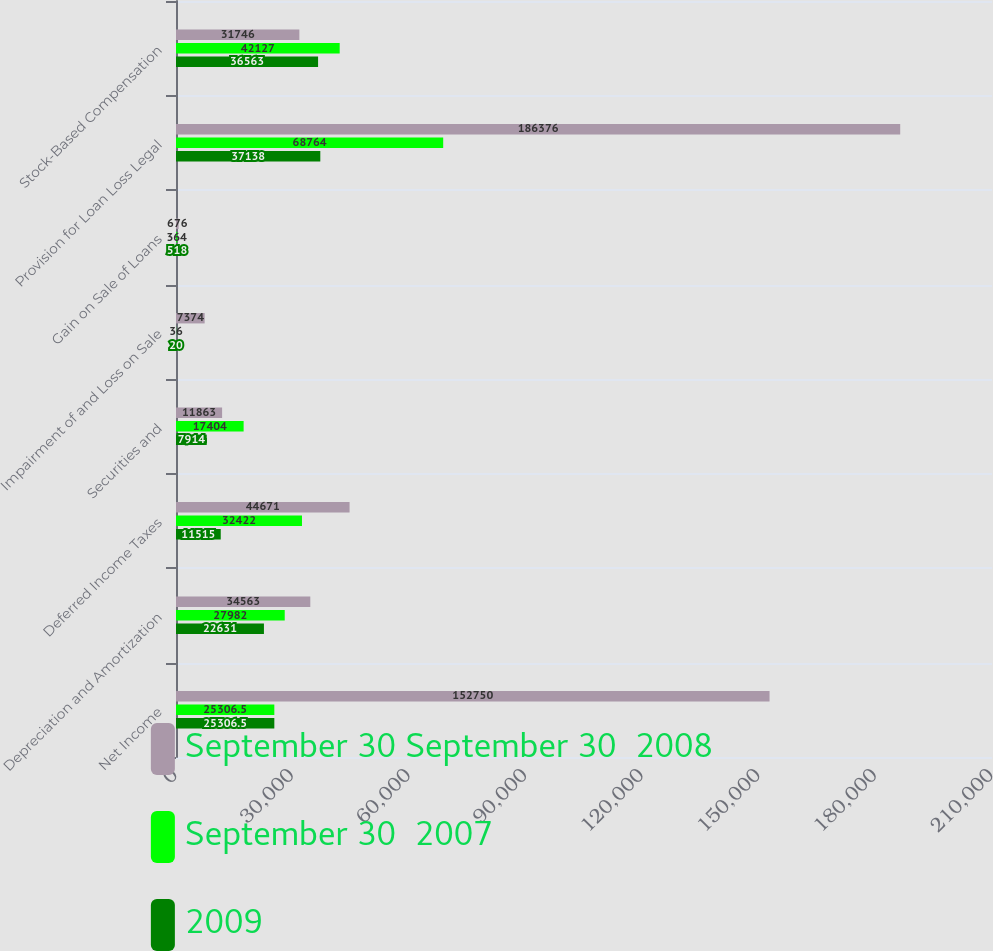<chart> <loc_0><loc_0><loc_500><loc_500><stacked_bar_chart><ecel><fcel>Net Income<fcel>Depreciation and Amortization<fcel>Deferred Income Taxes<fcel>Securities and<fcel>Impairment of and Loss on Sale<fcel>Gain on Sale of Loans<fcel>Provision for Loan Loss Legal<fcel>Stock-Based Compensation<nl><fcel>September 30 September 30  2008<fcel>152750<fcel>34563<fcel>44671<fcel>11863<fcel>7374<fcel>676<fcel>186376<fcel>31746<nl><fcel>September 30  2007<fcel>25306.5<fcel>27982<fcel>32422<fcel>17404<fcel>36<fcel>364<fcel>68764<fcel>42127<nl><fcel>2009<fcel>25306.5<fcel>22631<fcel>11515<fcel>7914<fcel>20<fcel>518<fcel>37138<fcel>36563<nl></chart> 